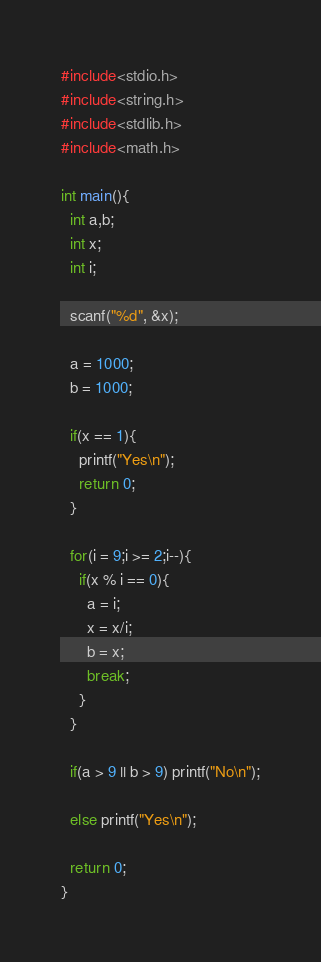Convert code to text. <code><loc_0><loc_0><loc_500><loc_500><_C_>#include<stdio.h>
#include<string.h>
#include<stdlib.h>
#include<math.h>

int main(){
  int a,b;
  int x;
  int i;

  scanf("%d", &x);

  a = 1000;
  b = 1000;

  if(x == 1){
    printf("Yes\n");
    return 0;
  }

  for(i = 9;i >= 2;i--){
    if(x % i == 0){
      a = i;
      x = x/i;
      b = x;
      break;
    }
  }

  if(a > 9 || b > 9) printf("No\n");

  else printf("Yes\n");

  return 0;
}
</code> 